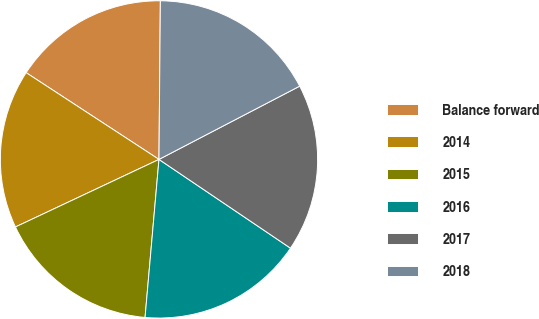Convert chart to OTSL. <chart><loc_0><loc_0><loc_500><loc_500><pie_chart><fcel>Balance forward<fcel>2014<fcel>2015<fcel>2016<fcel>2017<fcel>2018<nl><fcel>15.93%<fcel>16.21%<fcel>16.6%<fcel>16.95%<fcel>17.09%<fcel>17.22%<nl></chart> 